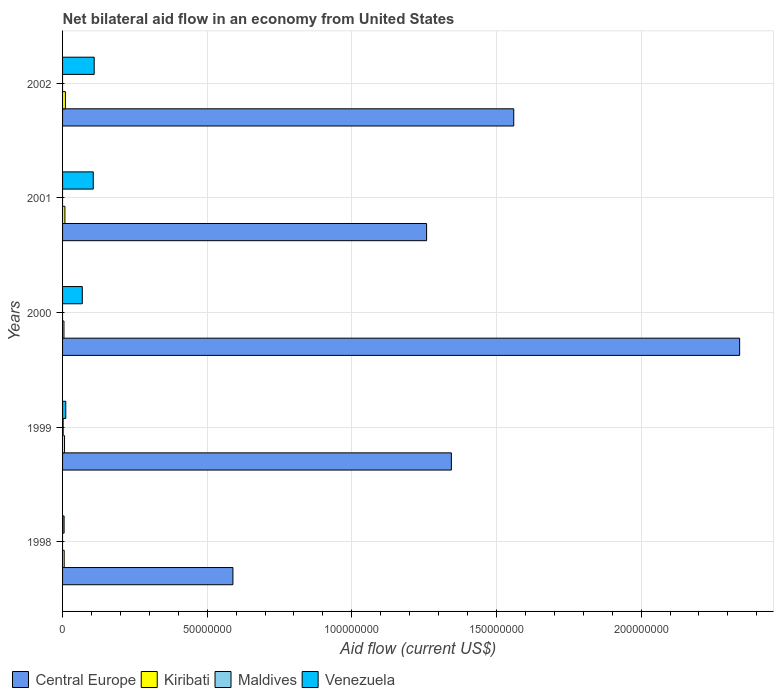How many different coloured bars are there?
Your answer should be very brief. 4. Are the number of bars per tick equal to the number of legend labels?
Offer a terse response. No. How many bars are there on the 1st tick from the top?
Keep it short and to the point. 3. In how many cases, is the number of bars for a given year not equal to the number of legend labels?
Provide a short and direct response. 4. What is the net bilateral aid flow in Venezuela in 1999?
Give a very brief answer. 1.11e+06. Across all years, what is the maximum net bilateral aid flow in Central Europe?
Your answer should be very brief. 2.34e+08. What is the total net bilateral aid flow in Maldives in the graph?
Offer a terse response. 2.00e+05. What is the difference between the net bilateral aid flow in Central Europe in 2000 and that in 2002?
Make the answer very short. 7.81e+07. What is the difference between the net bilateral aid flow in Central Europe in 2000 and the net bilateral aid flow in Venezuela in 2001?
Keep it short and to the point. 2.23e+08. What is the average net bilateral aid flow in Central Europe per year?
Give a very brief answer. 1.42e+08. In the year 2002, what is the difference between the net bilateral aid flow in Venezuela and net bilateral aid flow in Central Europe?
Your answer should be very brief. -1.45e+08. In how many years, is the net bilateral aid flow in Central Europe greater than 100000000 US$?
Ensure brevity in your answer.  4. What is the ratio of the net bilateral aid flow in Central Europe in 2000 to that in 2002?
Your response must be concise. 1.5. What is the difference between the highest and the second highest net bilateral aid flow in Central Europe?
Make the answer very short. 7.81e+07. How many bars are there?
Keep it short and to the point. 16. How many years are there in the graph?
Your answer should be compact. 5. What is the difference between two consecutive major ticks on the X-axis?
Make the answer very short. 5.00e+07. Does the graph contain any zero values?
Offer a very short reply. Yes. Does the graph contain grids?
Your answer should be compact. Yes. What is the title of the graph?
Give a very brief answer. Net bilateral aid flow in an economy from United States. Does "France" appear as one of the legend labels in the graph?
Your response must be concise. No. What is the label or title of the X-axis?
Your response must be concise. Aid flow (current US$). What is the Aid flow (current US$) of Central Europe in 1998?
Offer a very short reply. 5.89e+07. What is the Aid flow (current US$) in Kiribati in 1998?
Keep it short and to the point. 5.60e+05. What is the Aid flow (current US$) in Maldives in 1998?
Provide a short and direct response. 0. What is the Aid flow (current US$) in Venezuela in 1998?
Offer a very short reply. 5.30e+05. What is the Aid flow (current US$) in Central Europe in 1999?
Provide a short and direct response. 1.34e+08. What is the Aid flow (current US$) of Kiribati in 1999?
Offer a very short reply. 6.80e+05. What is the Aid flow (current US$) of Maldives in 1999?
Give a very brief answer. 2.00e+05. What is the Aid flow (current US$) of Venezuela in 1999?
Give a very brief answer. 1.11e+06. What is the Aid flow (current US$) of Central Europe in 2000?
Keep it short and to the point. 2.34e+08. What is the Aid flow (current US$) of Maldives in 2000?
Keep it short and to the point. 0. What is the Aid flow (current US$) of Venezuela in 2000?
Keep it short and to the point. 6.82e+06. What is the Aid flow (current US$) in Central Europe in 2001?
Offer a terse response. 1.26e+08. What is the Aid flow (current US$) of Kiribati in 2001?
Ensure brevity in your answer.  8.10e+05. What is the Aid flow (current US$) in Maldives in 2001?
Ensure brevity in your answer.  0. What is the Aid flow (current US$) in Venezuela in 2001?
Provide a short and direct response. 1.06e+07. What is the Aid flow (current US$) in Central Europe in 2002?
Give a very brief answer. 1.56e+08. What is the Aid flow (current US$) of Kiribati in 2002?
Provide a succinct answer. 9.80e+05. What is the Aid flow (current US$) of Venezuela in 2002?
Provide a succinct answer. 1.09e+07. Across all years, what is the maximum Aid flow (current US$) in Central Europe?
Keep it short and to the point. 2.34e+08. Across all years, what is the maximum Aid flow (current US$) in Kiribati?
Make the answer very short. 9.80e+05. Across all years, what is the maximum Aid flow (current US$) of Maldives?
Your response must be concise. 2.00e+05. Across all years, what is the maximum Aid flow (current US$) of Venezuela?
Provide a short and direct response. 1.09e+07. Across all years, what is the minimum Aid flow (current US$) of Central Europe?
Ensure brevity in your answer.  5.89e+07. Across all years, what is the minimum Aid flow (current US$) in Kiribati?
Your answer should be compact. 4.80e+05. Across all years, what is the minimum Aid flow (current US$) in Venezuela?
Your answer should be very brief. 5.30e+05. What is the total Aid flow (current US$) of Central Europe in the graph?
Your response must be concise. 7.09e+08. What is the total Aid flow (current US$) in Kiribati in the graph?
Your answer should be very brief. 3.51e+06. What is the total Aid flow (current US$) in Venezuela in the graph?
Your answer should be very brief. 3.00e+07. What is the difference between the Aid flow (current US$) in Central Europe in 1998 and that in 1999?
Your response must be concise. -7.55e+07. What is the difference between the Aid flow (current US$) in Kiribati in 1998 and that in 1999?
Give a very brief answer. -1.20e+05. What is the difference between the Aid flow (current US$) in Venezuela in 1998 and that in 1999?
Provide a short and direct response. -5.80e+05. What is the difference between the Aid flow (current US$) in Central Europe in 1998 and that in 2000?
Give a very brief answer. -1.75e+08. What is the difference between the Aid flow (current US$) of Kiribati in 1998 and that in 2000?
Offer a very short reply. 8.00e+04. What is the difference between the Aid flow (current US$) in Venezuela in 1998 and that in 2000?
Offer a terse response. -6.29e+06. What is the difference between the Aid flow (current US$) in Central Europe in 1998 and that in 2001?
Your response must be concise. -6.70e+07. What is the difference between the Aid flow (current US$) of Venezuela in 1998 and that in 2001?
Keep it short and to the point. -1.01e+07. What is the difference between the Aid flow (current US$) of Central Europe in 1998 and that in 2002?
Your answer should be compact. -9.71e+07. What is the difference between the Aid flow (current US$) of Kiribati in 1998 and that in 2002?
Offer a terse response. -4.20e+05. What is the difference between the Aid flow (current US$) of Venezuela in 1998 and that in 2002?
Your answer should be compact. -1.04e+07. What is the difference between the Aid flow (current US$) of Central Europe in 1999 and that in 2000?
Give a very brief answer. -9.96e+07. What is the difference between the Aid flow (current US$) of Venezuela in 1999 and that in 2000?
Offer a very short reply. -5.71e+06. What is the difference between the Aid flow (current US$) of Central Europe in 1999 and that in 2001?
Keep it short and to the point. 8.57e+06. What is the difference between the Aid flow (current US$) in Venezuela in 1999 and that in 2001?
Ensure brevity in your answer.  -9.50e+06. What is the difference between the Aid flow (current US$) in Central Europe in 1999 and that in 2002?
Keep it short and to the point. -2.16e+07. What is the difference between the Aid flow (current US$) in Kiribati in 1999 and that in 2002?
Your answer should be very brief. -3.00e+05. What is the difference between the Aid flow (current US$) of Venezuela in 1999 and that in 2002?
Offer a terse response. -9.82e+06. What is the difference between the Aid flow (current US$) in Central Europe in 2000 and that in 2001?
Offer a terse response. 1.08e+08. What is the difference between the Aid flow (current US$) of Kiribati in 2000 and that in 2001?
Provide a succinct answer. -3.30e+05. What is the difference between the Aid flow (current US$) of Venezuela in 2000 and that in 2001?
Keep it short and to the point. -3.79e+06. What is the difference between the Aid flow (current US$) of Central Europe in 2000 and that in 2002?
Your answer should be compact. 7.81e+07. What is the difference between the Aid flow (current US$) in Kiribati in 2000 and that in 2002?
Offer a terse response. -5.00e+05. What is the difference between the Aid flow (current US$) in Venezuela in 2000 and that in 2002?
Make the answer very short. -4.11e+06. What is the difference between the Aid flow (current US$) of Central Europe in 2001 and that in 2002?
Provide a succinct answer. -3.01e+07. What is the difference between the Aid flow (current US$) of Kiribati in 2001 and that in 2002?
Offer a very short reply. -1.70e+05. What is the difference between the Aid flow (current US$) in Venezuela in 2001 and that in 2002?
Your answer should be very brief. -3.20e+05. What is the difference between the Aid flow (current US$) of Central Europe in 1998 and the Aid flow (current US$) of Kiribati in 1999?
Keep it short and to the point. 5.82e+07. What is the difference between the Aid flow (current US$) in Central Europe in 1998 and the Aid flow (current US$) in Maldives in 1999?
Your answer should be compact. 5.87e+07. What is the difference between the Aid flow (current US$) of Central Europe in 1998 and the Aid flow (current US$) of Venezuela in 1999?
Ensure brevity in your answer.  5.78e+07. What is the difference between the Aid flow (current US$) of Kiribati in 1998 and the Aid flow (current US$) of Venezuela in 1999?
Give a very brief answer. -5.50e+05. What is the difference between the Aid flow (current US$) in Central Europe in 1998 and the Aid flow (current US$) in Kiribati in 2000?
Give a very brief answer. 5.84e+07. What is the difference between the Aid flow (current US$) in Central Europe in 1998 and the Aid flow (current US$) in Venezuela in 2000?
Your answer should be compact. 5.21e+07. What is the difference between the Aid flow (current US$) of Kiribati in 1998 and the Aid flow (current US$) of Venezuela in 2000?
Keep it short and to the point. -6.26e+06. What is the difference between the Aid flow (current US$) of Central Europe in 1998 and the Aid flow (current US$) of Kiribati in 2001?
Make the answer very short. 5.81e+07. What is the difference between the Aid flow (current US$) of Central Europe in 1998 and the Aid flow (current US$) of Venezuela in 2001?
Give a very brief answer. 4.83e+07. What is the difference between the Aid flow (current US$) of Kiribati in 1998 and the Aid flow (current US$) of Venezuela in 2001?
Offer a very short reply. -1.00e+07. What is the difference between the Aid flow (current US$) of Central Europe in 1998 and the Aid flow (current US$) of Kiribati in 2002?
Keep it short and to the point. 5.79e+07. What is the difference between the Aid flow (current US$) of Central Europe in 1998 and the Aid flow (current US$) of Venezuela in 2002?
Provide a short and direct response. 4.80e+07. What is the difference between the Aid flow (current US$) of Kiribati in 1998 and the Aid flow (current US$) of Venezuela in 2002?
Your response must be concise. -1.04e+07. What is the difference between the Aid flow (current US$) in Central Europe in 1999 and the Aid flow (current US$) in Kiribati in 2000?
Your response must be concise. 1.34e+08. What is the difference between the Aid flow (current US$) in Central Europe in 1999 and the Aid flow (current US$) in Venezuela in 2000?
Offer a very short reply. 1.28e+08. What is the difference between the Aid flow (current US$) of Kiribati in 1999 and the Aid flow (current US$) of Venezuela in 2000?
Offer a terse response. -6.14e+06. What is the difference between the Aid flow (current US$) of Maldives in 1999 and the Aid flow (current US$) of Venezuela in 2000?
Provide a succinct answer. -6.62e+06. What is the difference between the Aid flow (current US$) of Central Europe in 1999 and the Aid flow (current US$) of Kiribati in 2001?
Make the answer very short. 1.34e+08. What is the difference between the Aid flow (current US$) in Central Europe in 1999 and the Aid flow (current US$) in Venezuela in 2001?
Keep it short and to the point. 1.24e+08. What is the difference between the Aid flow (current US$) in Kiribati in 1999 and the Aid flow (current US$) in Venezuela in 2001?
Offer a very short reply. -9.93e+06. What is the difference between the Aid flow (current US$) of Maldives in 1999 and the Aid flow (current US$) of Venezuela in 2001?
Ensure brevity in your answer.  -1.04e+07. What is the difference between the Aid flow (current US$) in Central Europe in 1999 and the Aid flow (current US$) in Kiribati in 2002?
Offer a terse response. 1.33e+08. What is the difference between the Aid flow (current US$) of Central Europe in 1999 and the Aid flow (current US$) of Venezuela in 2002?
Your response must be concise. 1.23e+08. What is the difference between the Aid flow (current US$) of Kiribati in 1999 and the Aid flow (current US$) of Venezuela in 2002?
Your answer should be very brief. -1.02e+07. What is the difference between the Aid flow (current US$) in Maldives in 1999 and the Aid flow (current US$) in Venezuela in 2002?
Ensure brevity in your answer.  -1.07e+07. What is the difference between the Aid flow (current US$) in Central Europe in 2000 and the Aid flow (current US$) in Kiribati in 2001?
Make the answer very short. 2.33e+08. What is the difference between the Aid flow (current US$) of Central Europe in 2000 and the Aid flow (current US$) of Venezuela in 2001?
Your answer should be compact. 2.23e+08. What is the difference between the Aid flow (current US$) in Kiribati in 2000 and the Aid flow (current US$) in Venezuela in 2001?
Make the answer very short. -1.01e+07. What is the difference between the Aid flow (current US$) of Central Europe in 2000 and the Aid flow (current US$) of Kiribati in 2002?
Provide a short and direct response. 2.33e+08. What is the difference between the Aid flow (current US$) of Central Europe in 2000 and the Aid flow (current US$) of Venezuela in 2002?
Offer a terse response. 2.23e+08. What is the difference between the Aid flow (current US$) in Kiribati in 2000 and the Aid flow (current US$) in Venezuela in 2002?
Keep it short and to the point. -1.04e+07. What is the difference between the Aid flow (current US$) of Central Europe in 2001 and the Aid flow (current US$) of Kiribati in 2002?
Make the answer very short. 1.25e+08. What is the difference between the Aid flow (current US$) of Central Europe in 2001 and the Aid flow (current US$) of Venezuela in 2002?
Make the answer very short. 1.15e+08. What is the difference between the Aid flow (current US$) of Kiribati in 2001 and the Aid flow (current US$) of Venezuela in 2002?
Provide a short and direct response. -1.01e+07. What is the average Aid flow (current US$) in Central Europe per year?
Offer a very short reply. 1.42e+08. What is the average Aid flow (current US$) of Kiribati per year?
Offer a very short reply. 7.02e+05. In the year 1998, what is the difference between the Aid flow (current US$) in Central Europe and Aid flow (current US$) in Kiribati?
Your response must be concise. 5.83e+07. In the year 1998, what is the difference between the Aid flow (current US$) of Central Europe and Aid flow (current US$) of Venezuela?
Keep it short and to the point. 5.84e+07. In the year 1999, what is the difference between the Aid flow (current US$) of Central Europe and Aid flow (current US$) of Kiribati?
Provide a short and direct response. 1.34e+08. In the year 1999, what is the difference between the Aid flow (current US$) in Central Europe and Aid flow (current US$) in Maldives?
Provide a short and direct response. 1.34e+08. In the year 1999, what is the difference between the Aid flow (current US$) of Central Europe and Aid flow (current US$) of Venezuela?
Offer a very short reply. 1.33e+08. In the year 1999, what is the difference between the Aid flow (current US$) of Kiribati and Aid flow (current US$) of Maldives?
Make the answer very short. 4.80e+05. In the year 1999, what is the difference between the Aid flow (current US$) in Kiribati and Aid flow (current US$) in Venezuela?
Offer a terse response. -4.30e+05. In the year 1999, what is the difference between the Aid flow (current US$) of Maldives and Aid flow (current US$) of Venezuela?
Keep it short and to the point. -9.10e+05. In the year 2000, what is the difference between the Aid flow (current US$) of Central Europe and Aid flow (current US$) of Kiribati?
Provide a short and direct response. 2.34e+08. In the year 2000, what is the difference between the Aid flow (current US$) of Central Europe and Aid flow (current US$) of Venezuela?
Provide a short and direct response. 2.27e+08. In the year 2000, what is the difference between the Aid flow (current US$) of Kiribati and Aid flow (current US$) of Venezuela?
Give a very brief answer. -6.34e+06. In the year 2001, what is the difference between the Aid flow (current US$) in Central Europe and Aid flow (current US$) in Kiribati?
Keep it short and to the point. 1.25e+08. In the year 2001, what is the difference between the Aid flow (current US$) of Central Europe and Aid flow (current US$) of Venezuela?
Your response must be concise. 1.15e+08. In the year 2001, what is the difference between the Aid flow (current US$) of Kiribati and Aid flow (current US$) of Venezuela?
Offer a terse response. -9.80e+06. In the year 2002, what is the difference between the Aid flow (current US$) in Central Europe and Aid flow (current US$) in Kiribati?
Offer a terse response. 1.55e+08. In the year 2002, what is the difference between the Aid flow (current US$) of Central Europe and Aid flow (current US$) of Venezuela?
Your answer should be compact. 1.45e+08. In the year 2002, what is the difference between the Aid flow (current US$) of Kiribati and Aid flow (current US$) of Venezuela?
Your response must be concise. -9.95e+06. What is the ratio of the Aid flow (current US$) in Central Europe in 1998 to that in 1999?
Your response must be concise. 0.44. What is the ratio of the Aid flow (current US$) of Kiribati in 1998 to that in 1999?
Provide a succinct answer. 0.82. What is the ratio of the Aid flow (current US$) in Venezuela in 1998 to that in 1999?
Give a very brief answer. 0.48. What is the ratio of the Aid flow (current US$) of Central Europe in 1998 to that in 2000?
Make the answer very short. 0.25. What is the ratio of the Aid flow (current US$) of Kiribati in 1998 to that in 2000?
Keep it short and to the point. 1.17. What is the ratio of the Aid flow (current US$) of Venezuela in 1998 to that in 2000?
Provide a short and direct response. 0.08. What is the ratio of the Aid flow (current US$) of Central Europe in 1998 to that in 2001?
Provide a short and direct response. 0.47. What is the ratio of the Aid flow (current US$) in Kiribati in 1998 to that in 2001?
Offer a terse response. 0.69. What is the ratio of the Aid flow (current US$) in Central Europe in 1998 to that in 2002?
Your answer should be very brief. 0.38. What is the ratio of the Aid flow (current US$) of Venezuela in 1998 to that in 2002?
Provide a short and direct response. 0.05. What is the ratio of the Aid flow (current US$) of Central Europe in 1999 to that in 2000?
Offer a very short reply. 0.57. What is the ratio of the Aid flow (current US$) in Kiribati in 1999 to that in 2000?
Give a very brief answer. 1.42. What is the ratio of the Aid flow (current US$) in Venezuela in 1999 to that in 2000?
Offer a terse response. 0.16. What is the ratio of the Aid flow (current US$) in Central Europe in 1999 to that in 2001?
Provide a short and direct response. 1.07. What is the ratio of the Aid flow (current US$) of Kiribati in 1999 to that in 2001?
Ensure brevity in your answer.  0.84. What is the ratio of the Aid flow (current US$) of Venezuela in 1999 to that in 2001?
Offer a very short reply. 0.1. What is the ratio of the Aid flow (current US$) in Central Europe in 1999 to that in 2002?
Offer a terse response. 0.86. What is the ratio of the Aid flow (current US$) of Kiribati in 1999 to that in 2002?
Ensure brevity in your answer.  0.69. What is the ratio of the Aid flow (current US$) in Venezuela in 1999 to that in 2002?
Your response must be concise. 0.1. What is the ratio of the Aid flow (current US$) of Central Europe in 2000 to that in 2001?
Your answer should be compact. 1.86. What is the ratio of the Aid flow (current US$) in Kiribati in 2000 to that in 2001?
Your answer should be compact. 0.59. What is the ratio of the Aid flow (current US$) in Venezuela in 2000 to that in 2001?
Offer a very short reply. 0.64. What is the ratio of the Aid flow (current US$) in Central Europe in 2000 to that in 2002?
Provide a short and direct response. 1.5. What is the ratio of the Aid flow (current US$) of Kiribati in 2000 to that in 2002?
Offer a very short reply. 0.49. What is the ratio of the Aid flow (current US$) of Venezuela in 2000 to that in 2002?
Ensure brevity in your answer.  0.62. What is the ratio of the Aid flow (current US$) of Central Europe in 2001 to that in 2002?
Make the answer very short. 0.81. What is the ratio of the Aid flow (current US$) in Kiribati in 2001 to that in 2002?
Offer a very short reply. 0.83. What is the ratio of the Aid flow (current US$) in Venezuela in 2001 to that in 2002?
Your response must be concise. 0.97. What is the difference between the highest and the second highest Aid flow (current US$) of Central Europe?
Ensure brevity in your answer.  7.81e+07. What is the difference between the highest and the second highest Aid flow (current US$) of Kiribati?
Provide a succinct answer. 1.70e+05. What is the difference between the highest and the second highest Aid flow (current US$) in Venezuela?
Provide a succinct answer. 3.20e+05. What is the difference between the highest and the lowest Aid flow (current US$) of Central Europe?
Your answer should be compact. 1.75e+08. What is the difference between the highest and the lowest Aid flow (current US$) of Kiribati?
Ensure brevity in your answer.  5.00e+05. What is the difference between the highest and the lowest Aid flow (current US$) in Venezuela?
Give a very brief answer. 1.04e+07. 